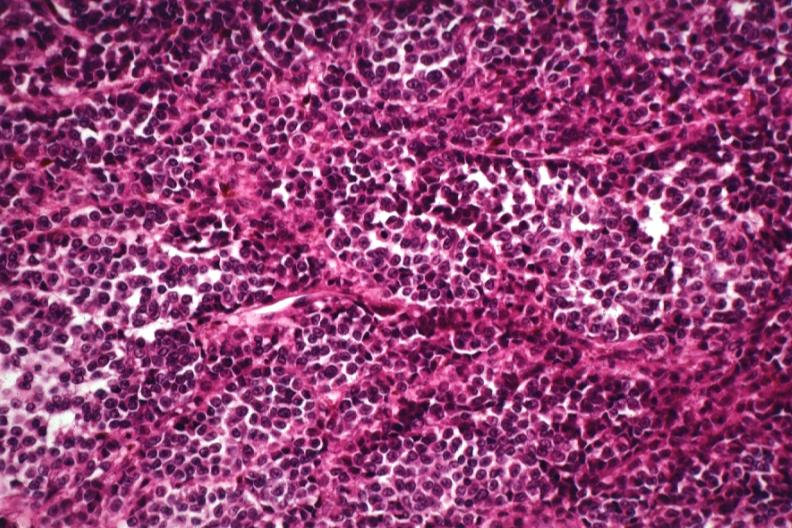does lesion of myocytolysis show cells deep in skin lesion with no pigment?
Answer the question using a single word or phrase. No 